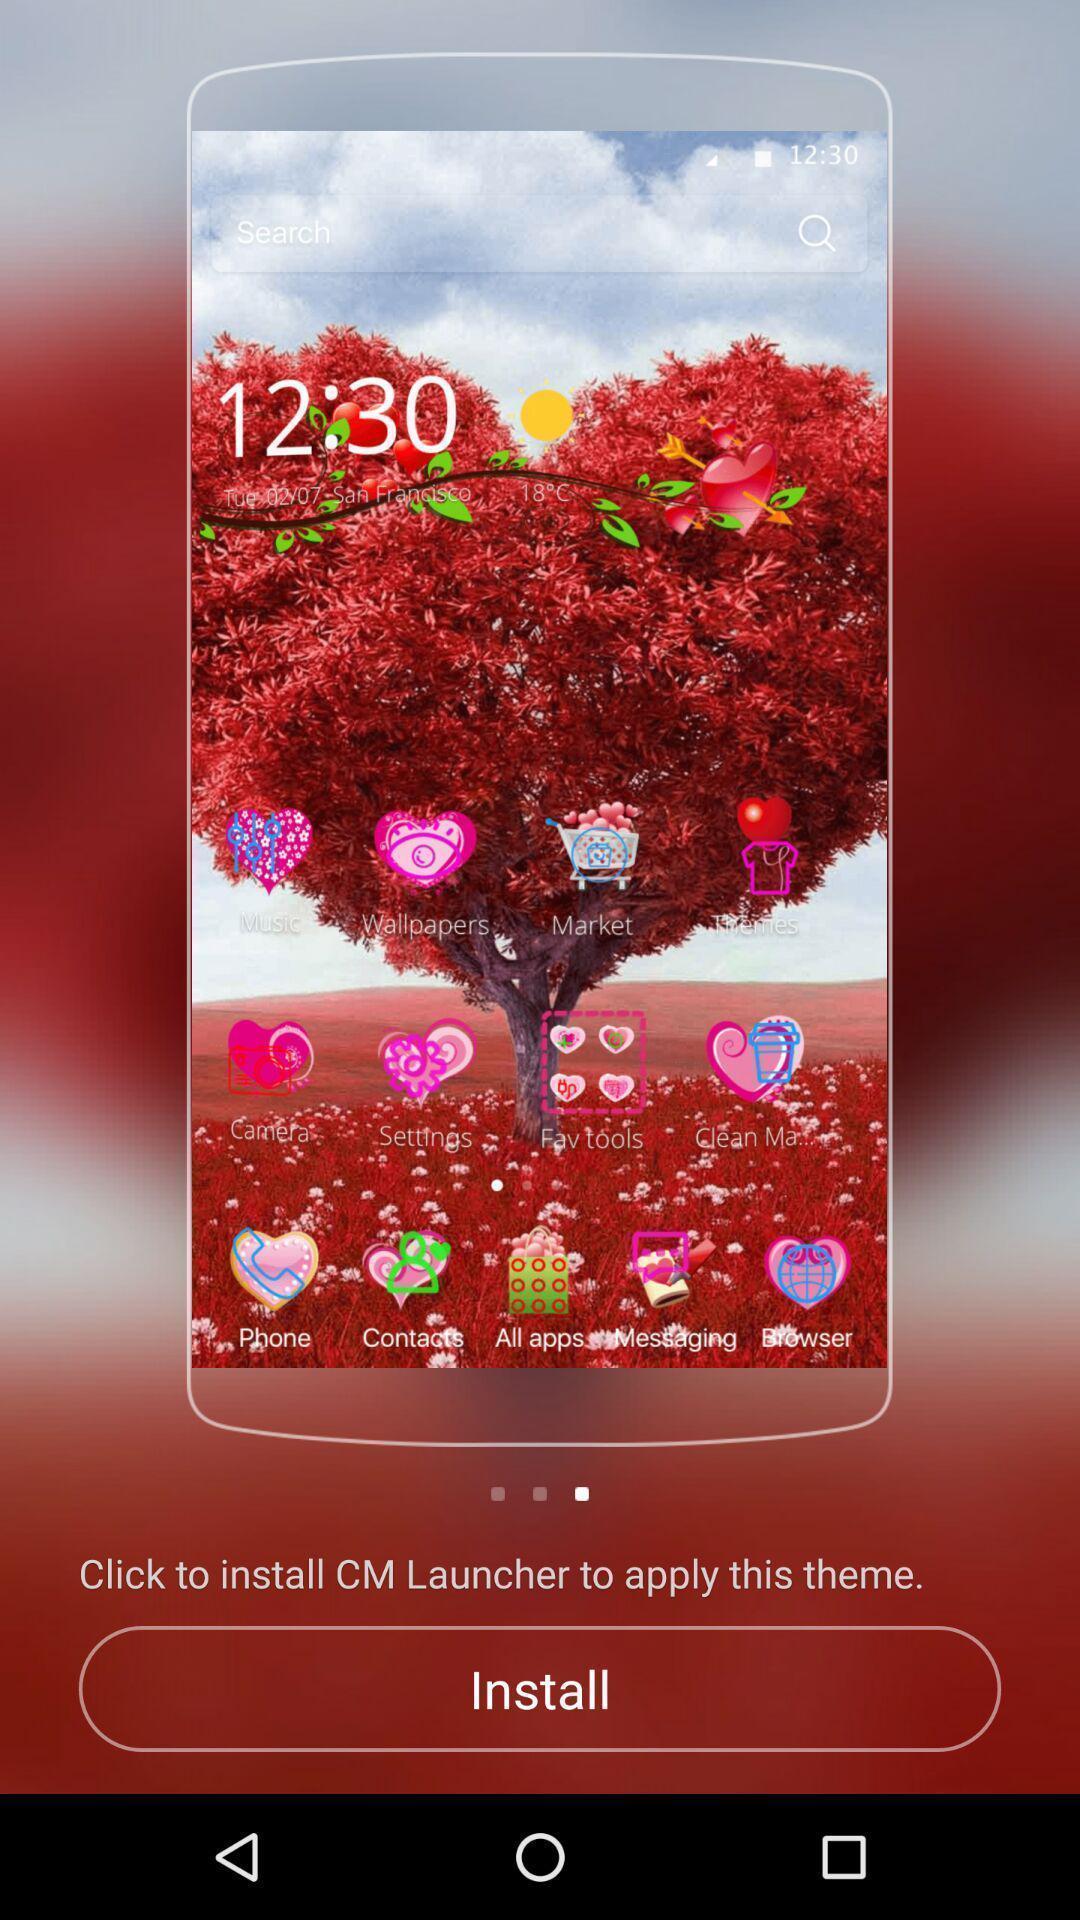What is the overall content of this screenshot? Welcome page. 